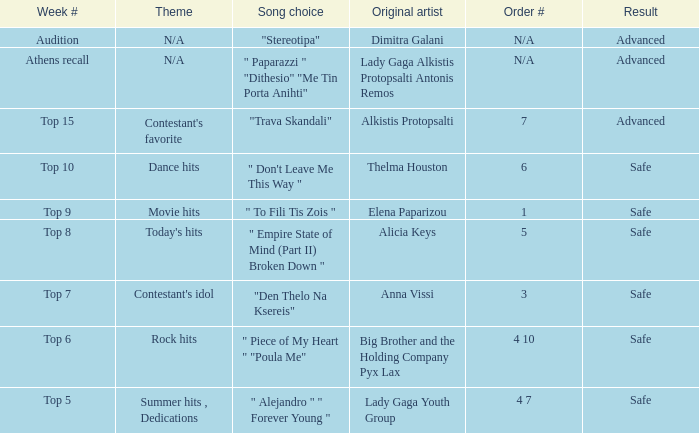Which artists hold order # 1? Elena Paparizou. 